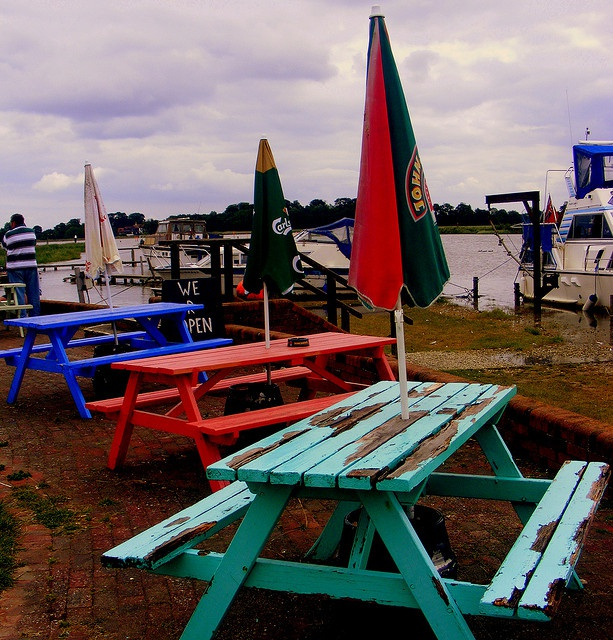Describe the objects in this image and their specific colors. I can see bench in lightgray, black, teal, lightblue, and maroon tones, bench in lightgray, black, maroon, and salmon tones, umbrella in lightgray, brown, black, and maroon tones, boat in lightgray, black, darkgray, navy, and gray tones, and umbrella in lightgray, black, maroon, and brown tones in this image. 